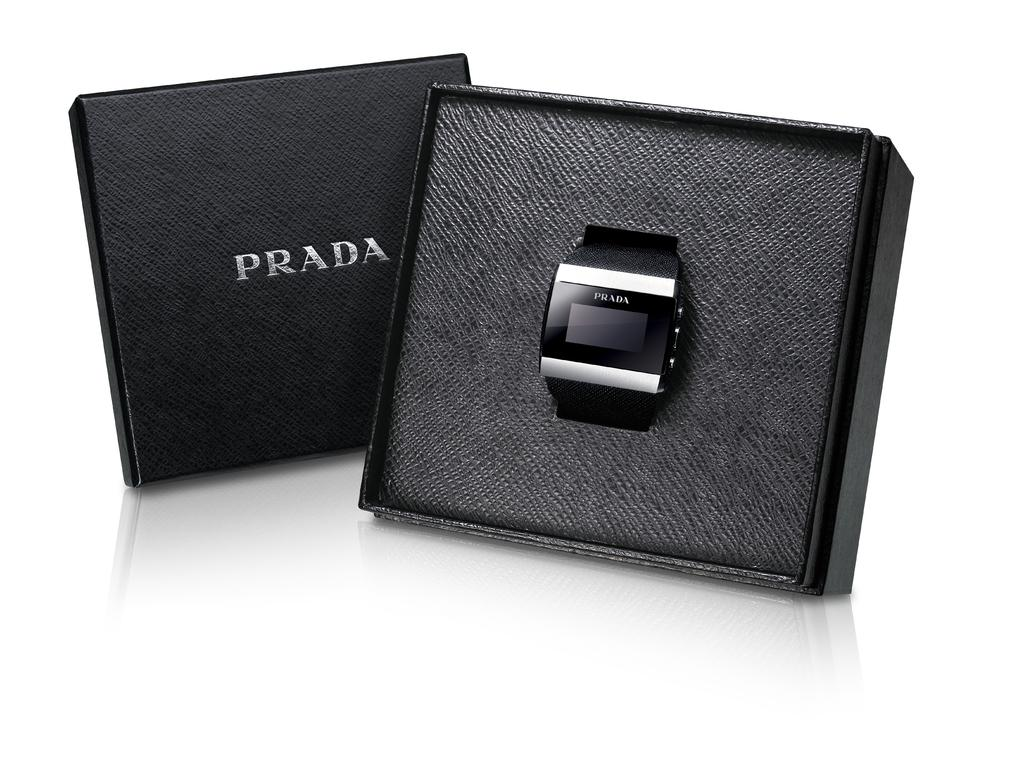<image>
Relay a brief, clear account of the picture shown. A PRADA smart watch placed in a black box. 